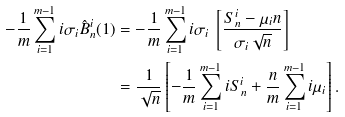Convert formula to latex. <formula><loc_0><loc_0><loc_500><loc_500>- \frac { 1 } { m } \sum ^ { m - 1 } _ { i = 1 } i \sigma _ { i } \hat { B } ^ { i } _ { n } ( 1 ) & = - \frac { 1 } { m } \sum ^ { m - 1 } _ { i = 1 } i \sigma _ { i } \ \left [ \frac { S ^ { i } _ { n } - \mu _ { i } n } { \sigma _ { i } \sqrt { n } } \right ] \\ & = \frac { 1 } { \sqrt { n } } \left [ - \frac { 1 } { m } \sum ^ { m - 1 } _ { i = 1 } i S ^ { i } _ { n } + \frac { n } { m } \sum ^ { m - 1 } _ { i = 1 } i \mu _ { i } \right ] .</formula> 